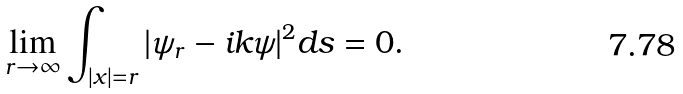Convert formula to latex. <formula><loc_0><loc_0><loc_500><loc_500>\lim _ { r \rightarrow \infty } \int _ { | x | = r } | \psi _ { r } - i k \psi | ^ { 2 } d s = 0 . \,</formula> 